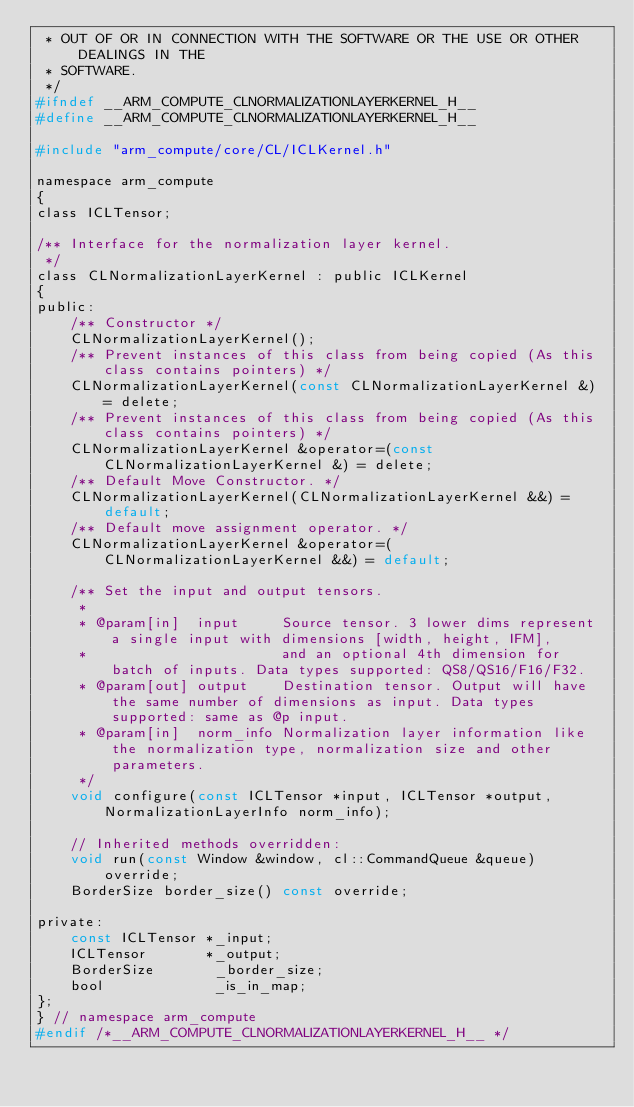<code> <loc_0><loc_0><loc_500><loc_500><_C_> * OUT OF OR IN CONNECTION WITH THE SOFTWARE OR THE USE OR OTHER DEALINGS IN THE
 * SOFTWARE.
 */
#ifndef __ARM_COMPUTE_CLNORMALIZATIONLAYERKERNEL_H__
#define __ARM_COMPUTE_CLNORMALIZATIONLAYERKERNEL_H__

#include "arm_compute/core/CL/ICLKernel.h"

namespace arm_compute
{
class ICLTensor;

/** Interface for the normalization layer kernel.
 */
class CLNormalizationLayerKernel : public ICLKernel
{
public:
    /** Constructor */
    CLNormalizationLayerKernel();
    /** Prevent instances of this class from being copied (As this class contains pointers) */
    CLNormalizationLayerKernel(const CLNormalizationLayerKernel &) = delete;
    /** Prevent instances of this class from being copied (As this class contains pointers) */
    CLNormalizationLayerKernel &operator=(const CLNormalizationLayerKernel &) = delete;
    /** Default Move Constructor. */
    CLNormalizationLayerKernel(CLNormalizationLayerKernel &&) = default;
    /** Default move assignment operator. */
    CLNormalizationLayerKernel &operator=(CLNormalizationLayerKernel &&) = default;

    /** Set the input and output tensors.
     *
     * @param[in]  input     Source tensor. 3 lower dims represent a single input with dimensions [width, height, IFM],
     *                       and an optional 4th dimension for batch of inputs. Data types supported: QS8/QS16/F16/F32.
     * @param[out] output    Destination tensor. Output will have the same number of dimensions as input. Data types supported: same as @p input.
     * @param[in]  norm_info Normalization layer information like the normalization type, normalization size and other parameters.
     */
    void configure(const ICLTensor *input, ICLTensor *output, NormalizationLayerInfo norm_info);

    // Inherited methods overridden:
    void run(const Window &window, cl::CommandQueue &queue) override;
    BorderSize border_size() const override;

private:
    const ICLTensor *_input;
    ICLTensor       *_output;
    BorderSize       _border_size;
    bool             _is_in_map;
};
} // namespace arm_compute
#endif /*__ARM_COMPUTE_CLNORMALIZATIONLAYERKERNEL_H__ */
</code> 